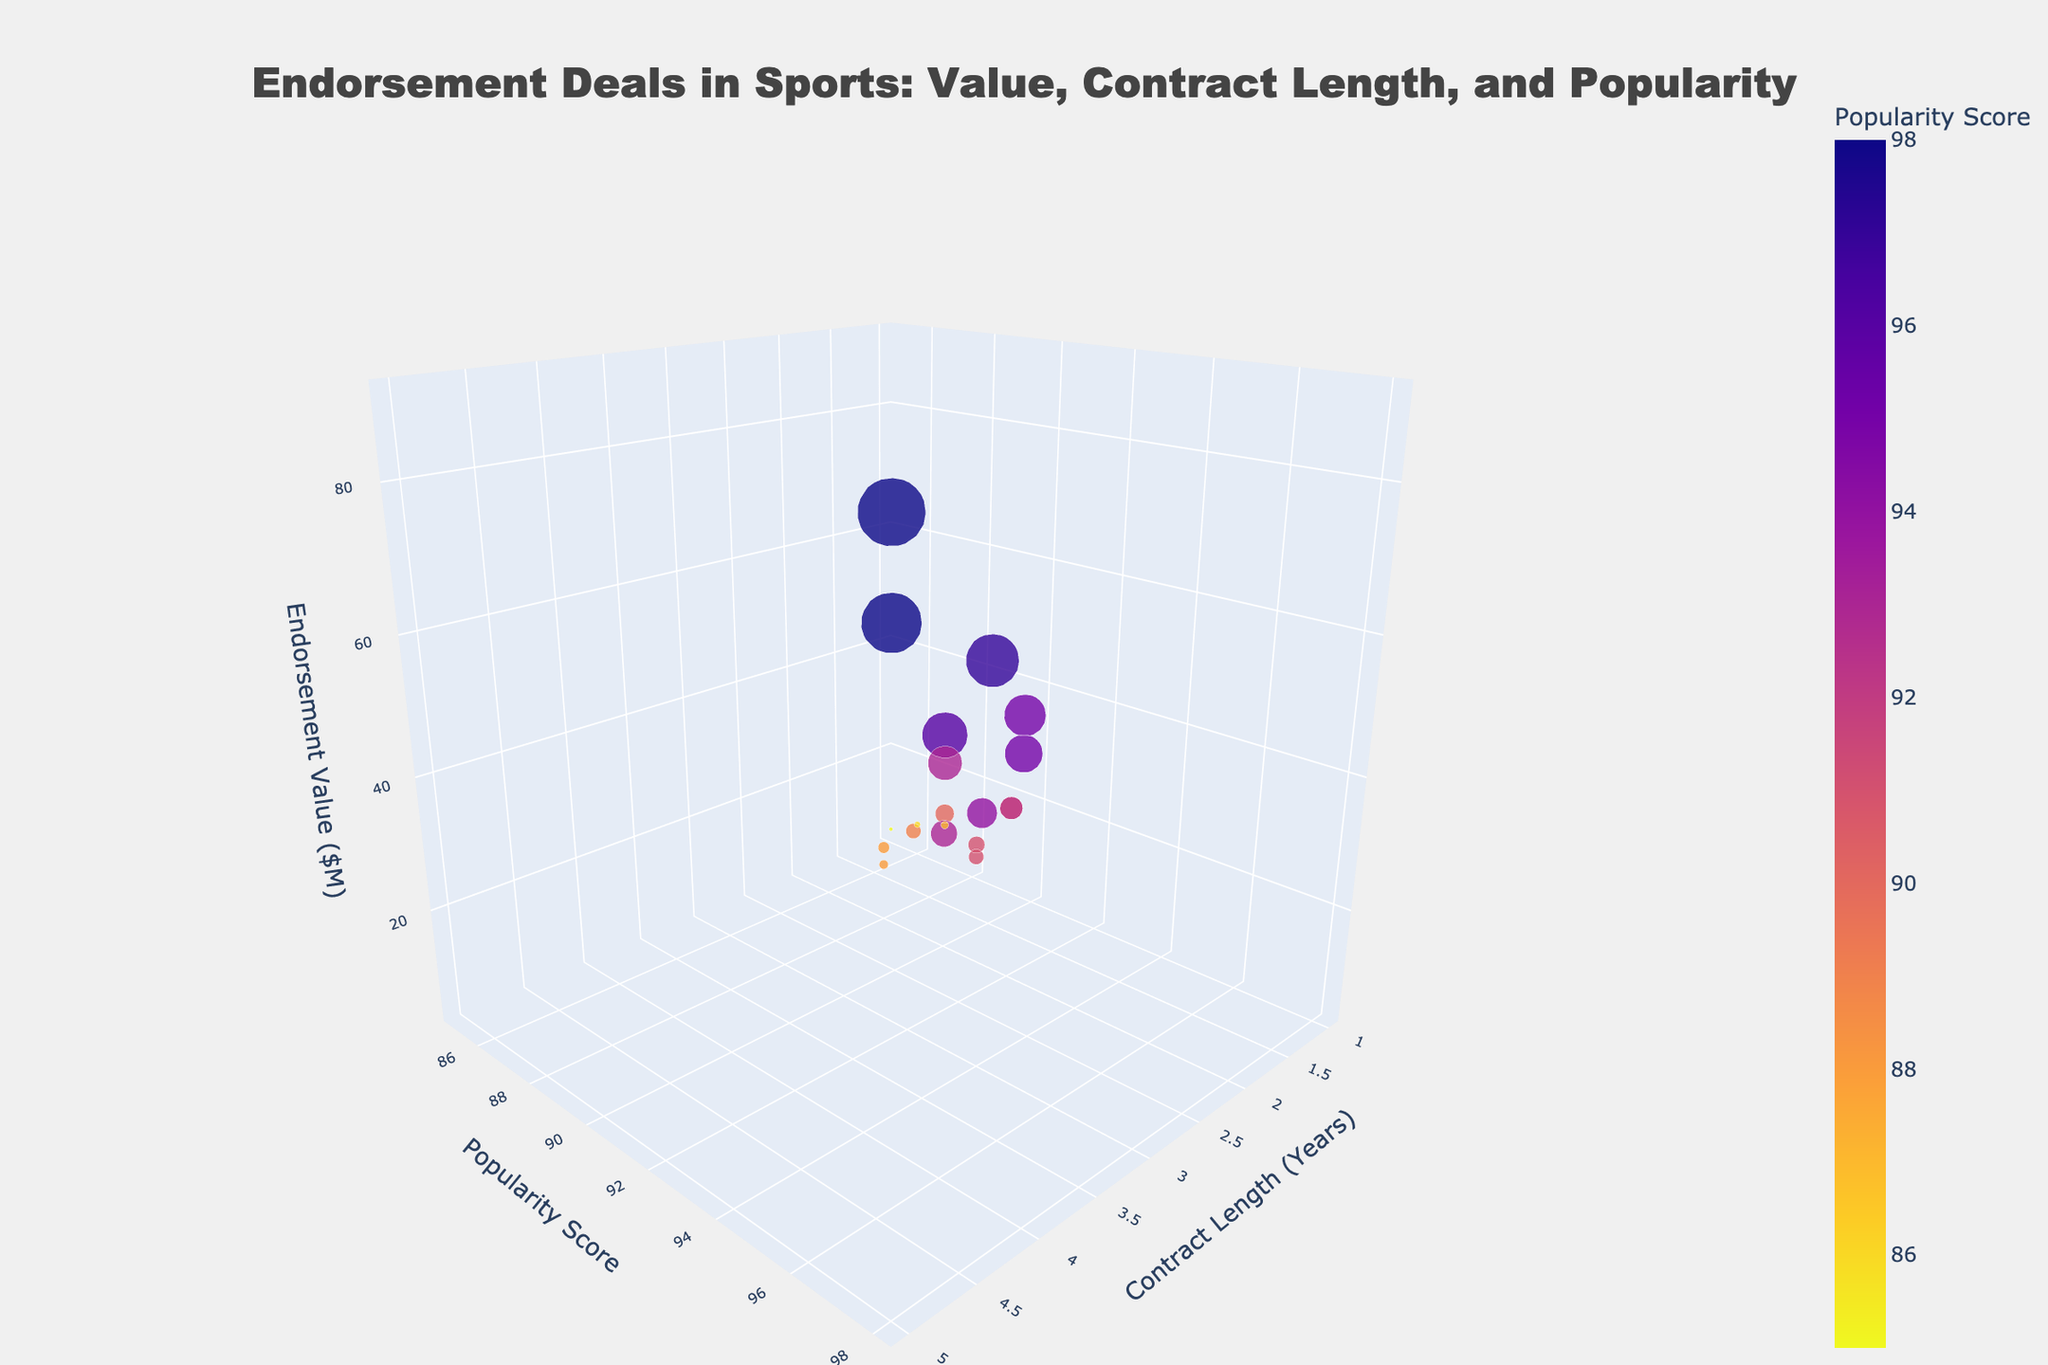What's the title of the plot? The title usually appears at the top of the plot and provides an overview of what the plot represents, which can be directly read from the figure.
Answer: Endorsement Deals in Sports: Value, Contract Length, and Popularity What is the x-axis representing? The label on the x-axis of the plot indicates what dimension it measures, which can be seen directly on the figure.
Answer: Contract Length (Years) What is the y-axis representing? The label on the y-axis of the plot indicates what dimension it measures, which can be seen directly on the figure.
Answer: Popularity Score What is the size of the marker for LeBron James? The size of the marker can be determined by looking at the figure and understanding that the marker size is proportional to the endorsement value. The exact size is mentioned in the question.
Answer: 45 Who has the highest endorsement value and how much is it? The marker with the highest z-coordinate will indicate the athlete with the highest endorsement value, which can be directly read from the plot.
Answer: LeBron James, $90M Compare the endorsement values of Lionel Messi and Cristiano Ronaldo. Who has a higher endorsement value? By locating the markers for Lionel Messi and Cristiano Ronaldo and comparing their z-coordinates, we can determine who has a higher endorsement value.
Answer: Lionel Messi Which athlete has the lowest popularity score and what is their endorsement value? The marker with the lowest y-coordinate will indicate the athlete with the lowest popularity score, and their z-coordinate will provide the corresponding endorsement value.
Answer: Eliud Kipchoge, $5M How many athletes have a contract length of 2 years? By counting the number of markers positioned at the x-coordinate indicating 2 years, we can determine the number of athletes with this contract length.
Answer: 8 What is the average endorsement value for athletes with a popularity score of 95 and above? First, identify athletes with a popularity score of 95 and above by looking at markers with y-coordinates 95 and above. Then, sum their endorsement values and divide by the number of those athletes to get the average.
Answer: 62.5 Which athlete has the longest contract length and what is their popularity score? The marker with the highest x-coordinate indicates the athlete with the longest contract length. Their popularity score can be read directly from the y-coordinate.
Answer: LeBron James, 98 